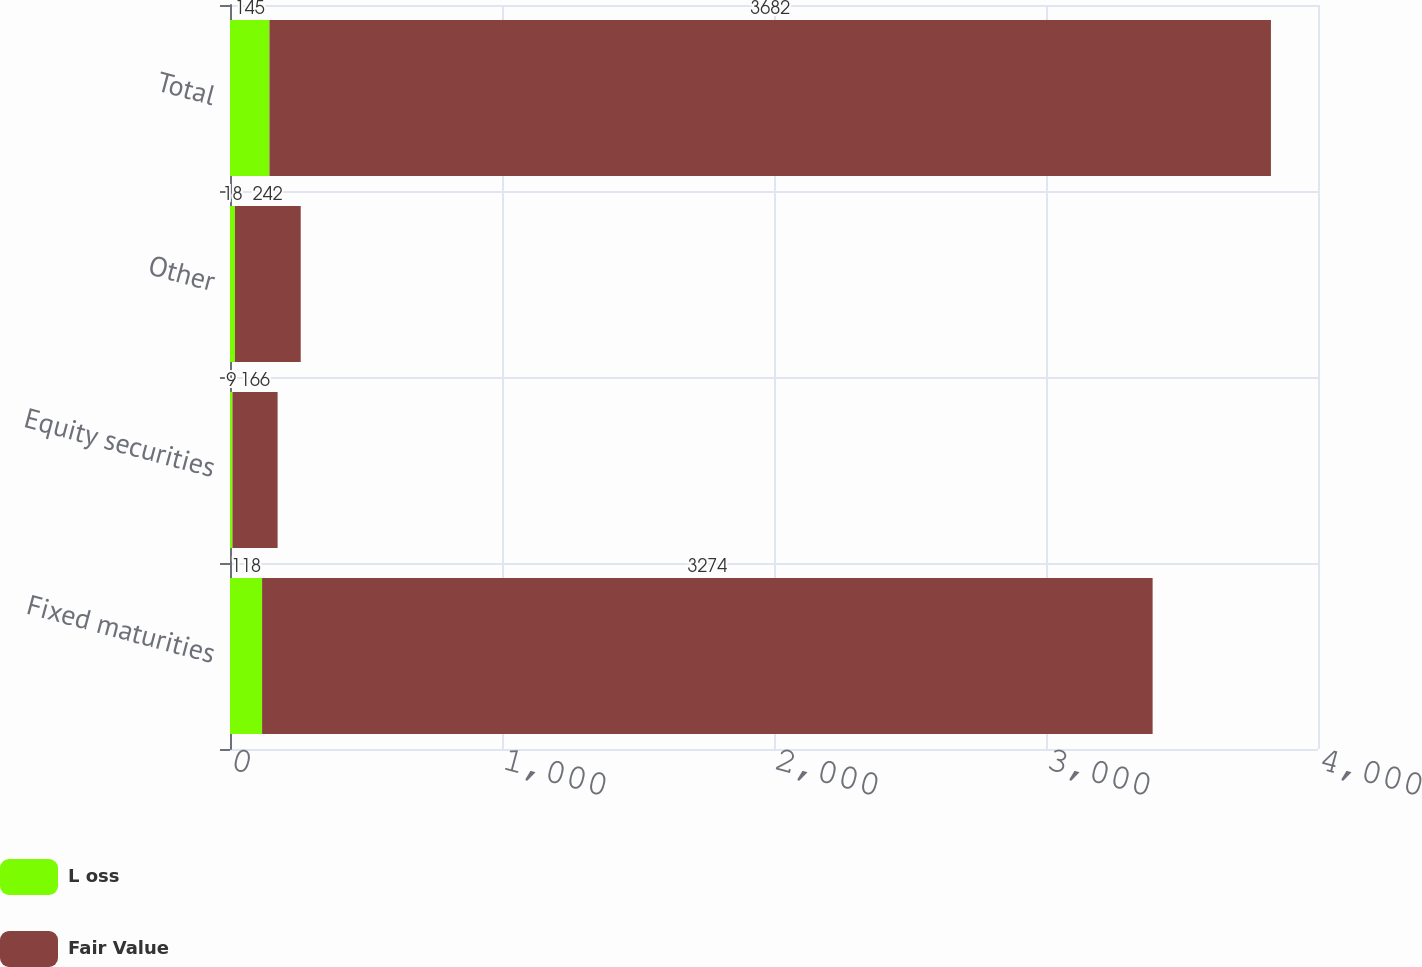Convert chart to OTSL. <chart><loc_0><loc_0><loc_500><loc_500><stacked_bar_chart><ecel><fcel>Fixed maturities<fcel>Equity securities<fcel>Other<fcel>Total<nl><fcel>L oss<fcel>118<fcel>9<fcel>18<fcel>145<nl><fcel>Fair Value<fcel>3274<fcel>166<fcel>242<fcel>3682<nl></chart> 